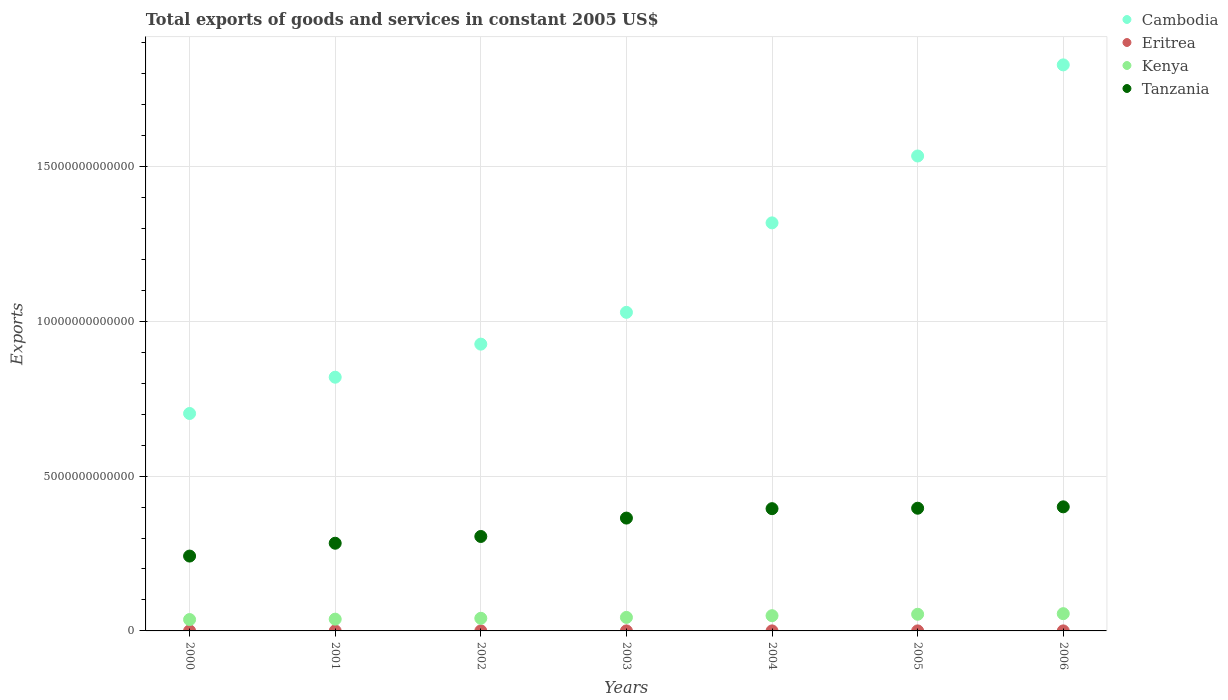Is the number of dotlines equal to the number of legend labels?
Offer a terse response. Yes. What is the total exports of goods and services in Eritrea in 2006?
Offer a terse response. 7.80e+08. Across all years, what is the maximum total exports of goods and services in Tanzania?
Make the answer very short. 4.01e+12. Across all years, what is the minimum total exports of goods and services in Tanzania?
Keep it short and to the point. 2.42e+12. What is the total total exports of goods and services in Eritrea in the graph?
Provide a short and direct response. 5.02e+09. What is the difference between the total exports of goods and services in Tanzania in 2003 and that in 2004?
Keep it short and to the point. -3.04e+11. What is the difference between the total exports of goods and services in Cambodia in 2006 and the total exports of goods and services in Kenya in 2000?
Keep it short and to the point. 1.79e+13. What is the average total exports of goods and services in Eritrea per year?
Ensure brevity in your answer.  7.17e+08. In the year 2005, what is the difference between the total exports of goods and services in Kenya and total exports of goods and services in Eritrea?
Offer a terse response. 5.37e+11. What is the ratio of the total exports of goods and services in Kenya in 2005 to that in 2006?
Your answer should be compact. 0.97. Is the difference between the total exports of goods and services in Kenya in 2000 and 2006 greater than the difference between the total exports of goods and services in Eritrea in 2000 and 2006?
Offer a terse response. No. What is the difference between the highest and the second highest total exports of goods and services in Kenya?
Give a very brief answer. 1.90e+1. What is the difference between the highest and the lowest total exports of goods and services in Cambodia?
Ensure brevity in your answer.  1.13e+13. In how many years, is the total exports of goods and services in Kenya greater than the average total exports of goods and services in Kenya taken over all years?
Make the answer very short. 3. Is the sum of the total exports of goods and services in Kenya in 2000 and 2002 greater than the maximum total exports of goods and services in Tanzania across all years?
Give a very brief answer. No. Is it the case that in every year, the sum of the total exports of goods and services in Kenya and total exports of goods and services in Cambodia  is greater than the sum of total exports of goods and services in Tanzania and total exports of goods and services in Eritrea?
Your answer should be very brief. Yes. Does the total exports of goods and services in Tanzania monotonically increase over the years?
Your answer should be very brief. Yes. Is the total exports of goods and services in Tanzania strictly greater than the total exports of goods and services in Eritrea over the years?
Offer a very short reply. Yes. How many years are there in the graph?
Your answer should be compact. 7. What is the difference between two consecutive major ticks on the Y-axis?
Your response must be concise. 5.00e+12. Are the values on the major ticks of Y-axis written in scientific E-notation?
Offer a terse response. No. Where does the legend appear in the graph?
Your answer should be compact. Top right. How are the legend labels stacked?
Your response must be concise. Vertical. What is the title of the graph?
Your answer should be compact. Total exports of goods and services in constant 2005 US$. Does "Kyrgyz Republic" appear as one of the legend labels in the graph?
Your answer should be very brief. No. What is the label or title of the X-axis?
Your answer should be very brief. Years. What is the label or title of the Y-axis?
Give a very brief answer. Exports. What is the Exports in Cambodia in 2000?
Your answer should be compact. 7.02e+12. What is the Exports in Eritrea in 2000?
Provide a short and direct response. 6.57e+08. What is the Exports of Kenya in 2000?
Your response must be concise. 3.67e+11. What is the Exports of Tanzania in 2000?
Your answer should be compact. 2.42e+12. What is the Exports in Cambodia in 2001?
Your answer should be compact. 8.19e+12. What is the Exports of Eritrea in 2001?
Offer a very short reply. 7.64e+08. What is the Exports of Kenya in 2001?
Ensure brevity in your answer.  3.80e+11. What is the Exports of Tanzania in 2001?
Offer a very short reply. 2.83e+12. What is the Exports in Cambodia in 2002?
Ensure brevity in your answer.  9.26e+12. What is the Exports of Eritrea in 2002?
Your response must be concise. 8.31e+08. What is the Exports of Kenya in 2002?
Offer a terse response. 4.07e+11. What is the Exports of Tanzania in 2002?
Your answer should be very brief. 3.05e+12. What is the Exports of Cambodia in 2003?
Your response must be concise. 1.03e+13. What is the Exports of Eritrea in 2003?
Your answer should be very brief. 6.21e+08. What is the Exports of Kenya in 2003?
Provide a short and direct response. 4.37e+11. What is the Exports in Tanzania in 2003?
Provide a short and direct response. 3.64e+12. What is the Exports in Cambodia in 2004?
Offer a terse response. 1.32e+13. What is the Exports of Eritrea in 2004?
Ensure brevity in your answer.  6.85e+08. What is the Exports in Kenya in 2004?
Offer a very short reply. 4.92e+11. What is the Exports in Tanzania in 2004?
Your answer should be very brief. 3.95e+12. What is the Exports of Cambodia in 2005?
Give a very brief answer. 1.53e+13. What is the Exports of Eritrea in 2005?
Your response must be concise. 6.78e+08. What is the Exports of Kenya in 2005?
Make the answer very short. 5.38e+11. What is the Exports of Tanzania in 2005?
Offer a terse response. 3.96e+12. What is the Exports in Cambodia in 2006?
Ensure brevity in your answer.  1.83e+13. What is the Exports in Eritrea in 2006?
Make the answer very short. 7.80e+08. What is the Exports in Kenya in 2006?
Give a very brief answer. 5.57e+11. What is the Exports of Tanzania in 2006?
Keep it short and to the point. 4.01e+12. Across all years, what is the maximum Exports of Cambodia?
Keep it short and to the point. 1.83e+13. Across all years, what is the maximum Exports in Eritrea?
Offer a very short reply. 8.31e+08. Across all years, what is the maximum Exports in Kenya?
Your answer should be very brief. 5.57e+11. Across all years, what is the maximum Exports in Tanzania?
Provide a short and direct response. 4.01e+12. Across all years, what is the minimum Exports in Cambodia?
Offer a terse response. 7.02e+12. Across all years, what is the minimum Exports in Eritrea?
Provide a short and direct response. 6.21e+08. Across all years, what is the minimum Exports in Kenya?
Offer a very short reply. 3.67e+11. Across all years, what is the minimum Exports of Tanzania?
Ensure brevity in your answer.  2.42e+12. What is the total Exports of Cambodia in the graph?
Your response must be concise. 8.15e+13. What is the total Exports of Eritrea in the graph?
Ensure brevity in your answer.  5.02e+09. What is the total Exports in Kenya in the graph?
Your response must be concise. 3.18e+12. What is the total Exports in Tanzania in the graph?
Your answer should be compact. 2.39e+13. What is the difference between the Exports of Cambodia in 2000 and that in 2001?
Provide a short and direct response. -1.17e+12. What is the difference between the Exports in Eritrea in 2000 and that in 2001?
Keep it short and to the point. -1.06e+08. What is the difference between the Exports of Kenya in 2000 and that in 2001?
Give a very brief answer. -1.32e+1. What is the difference between the Exports of Tanzania in 2000 and that in 2001?
Keep it short and to the point. -4.14e+11. What is the difference between the Exports of Cambodia in 2000 and that in 2002?
Provide a succinct answer. -2.24e+12. What is the difference between the Exports of Eritrea in 2000 and that in 2002?
Provide a short and direct response. -1.73e+08. What is the difference between the Exports in Kenya in 2000 and that in 2002?
Your response must be concise. -4.03e+1. What is the difference between the Exports of Tanzania in 2000 and that in 2002?
Offer a very short reply. -6.32e+11. What is the difference between the Exports in Cambodia in 2000 and that in 2003?
Keep it short and to the point. -3.27e+12. What is the difference between the Exports of Eritrea in 2000 and that in 2003?
Offer a terse response. 3.66e+07. What is the difference between the Exports of Kenya in 2000 and that in 2003?
Offer a very short reply. -6.97e+1. What is the difference between the Exports of Tanzania in 2000 and that in 2003?
Give a very brief answer. -1.23e+12. What is the difference between the Exports of Cambodia in 2000 and that in 2004?
Your response must be concise. -6.15e+12. What is the difference between the Exports in Eritrea in 2000 and that in 2004?
Keep it short and to the point. -2.75e+07. What is the difference between the Exports of Kenya in 2000 and that in 2004?
Offer a terse response. -1.25e+11. What is the difference between the Exports in Tanzania in 2000 and that in 2004?
Give a very brief answer. -1.53e+12. What is the difference between the Exports in Cambodia in 2000 and that in 2005?
Ensure brevity in your answer.  -8.31e+12. What is the difference between the Exports in Eritrea in 2000 and that in 2005?
Your response must be concise. -2.05e+07. What is the difference between the Exports in Kenya in 2000 and that in 2005?
Offer a very short reply. -1.71e+11. What is the difference between the Exports in Tanzania in 2000 and that in 2005?
Offer a terse response. -1.54e+12. What is the difference between the Exports of Cambodia in 2000 and that in 2006?
Offer a very short reply. -1.13e+13. What is the difference between the Exports in Eritrea in 2000 and that in 2006?
Make the answer very short. -1.23e+08. What is the difference between the Exports in Kenya in 2000 and that in 2006?
Your response must be concise. -1.90e+11. What is the difference between the Exports of Tanzania in 2000 and that in 2006?
Ensure brevity in your answer.  -1.59e+12. What is the difference between the Exports of Cambodia in 2001 and that in 2002?
Provide a succinct answer. -1.07e+12. What is the difference between the Exports in Eritrea in 2001 and that in 2002?
Give a very brief answer. -6.67e+07. What is the difference between the Exports in Kenya in 2001 and that in 2002?
Offer a terse response. -2.71e+1. What is the difference between the Exports of Tanzania in 2001 and that in 2002?
Give a very brief answer. -2.18e+11. What is the difference between the Exports in Cambodia in 2001 and that in 2003?
Your answer should be compact. -2.09e+12. What is the difference between the Exports of Eritrea in 2001 and that in 2003?
Provide a short and direct response. 1.43e+08. What is the difference between the Exports of Kenya in 2001 and that in 2003?
Offer a terse response. -5.64e+1. What is the difference between the Exports in Tanzania in 2001 and that in 2003?
Your answer should be very brief. -8.12e+11. What is the difference between the Exports in Cambodia in 2001 and that in 2004?
Offer a very short reply. -4.98e+12. What is the difference between the Exports of Eritrea in 2001 and that in 2004?
Keep it short and to the point. 7.90e+07. What is the difference between the Exports of Kenya in 2001 and that in 2004?
Ensure brevity in your answer.  -1.11e+11. What is the difference between the Exports in Tanzania in 2001 and that in 2004?
Your answer should be very brief. -1.12e+12. What is the difference between the Exports of Cambodia in 2001 and that in 2005?
Ensure brevity in your answer.  -7.14e+12. What is the difference between the Exports of Eritrea in 2001 and that in 2005?
Your response must be concise. 8.60e+07. What is the difference between the Exports of Kenya in 2001 and that in 2005?
Your answer should be compact. -1.58e+11. What is the difference between the Exports in Tanzania in 2001 and that in 2005?
Your answer should be very brief. -1.13e+12. What is the difference between the Exports in Cambodia in 2001 and that in 2006?
Give a very brief answer. -1.01e+13. What is the difference between the Exports of Eritrea in 2001 and that in 2006?
Provide a succinct answer. -1.63e+07. What is the difference between the Exports in Kenya in 2001 and that in 2006?
Provide a short and direct response. -1.77e+11. What is the difference between the Exports in Tanzania in 2001 and that in 2006?
Make the answer very short. -1.17e+12. What is the difference between the Exports of Cambodia in 2002 and that in 2003?
Your answer should be compact. -1.03e+12. What is the difference between the Exports in Eritrea in 2002 and that in 2003?
Your response must be concise. 2.10e+08. What is the difference between the Exports of Kenya in 2002 and that in 2003?
Give a very brief answer. -2.94e+1. What is the difference between the Exports of Tanzania in 2002 and that in 2003?
Your response must be concise. -5.94e+11. What is the difference between the Exports in Cambodia in 2002 and that in 2004?
Provide a short and direct response. -3.91e+12. What is the difference between the Exports of Eritrea in 2002 and that in 2004?
Give a very brief answer. 1.46e+08. What is the difference between the Exports of Kenya in 2002 and that in 2004?
Keep it short and to the point. -8.44e+1. What is the difference between the Exports of Tanzania in 2002 and that in 2004?
Keep it short and to the point. -8.98e+11. What is the difference between the Exports in Cambodia in 2002 and that in 2005?
Offer a terse response. -6.07e+12. What is the difference between the Exports of Eritrea in 2002 and that in 2005?
Provide a short and direct response. 1.53e+08. What is the difference between the Exports in Kenya in 2002 and that in 2005?
Your answer should be very brief. -1.31e+11. What is the difference between the Exports of Tanzania in 2002 and that in 2005?
Give a very brief answer. -9.12e+11. What is the difference between the Exports of Cambodia in 2002 and that in 2006?
Your answer should be very brief. -9.02e+12. What is the difference between the Exports in Eritrea in 2002 and that in 2006?
Your answer should be very brief. 5.03e+07. What is the difference between the Exports in Kenya in 2002 and that in 2006?
Provide a succinct answer. -1.50e+11. What is the difference between the Exports in Tanzania in 2002 and that in 2006?
Provide a succinct answer. -9.57e+11. What is the difference between the Exports in Cambodia in 2003 and that in 2004?
Ensure brevity in your answer.  -2.89e+12. What is the difference between the Exports in Eritrea in 2003 and that in 2004?
Offer a terse response. -6.41e+07. What is the difference between the Exports in Kenya in 2003 and that in 2004?
Provide a succinct answer. -5.50e+1. What is the difference between the Exports of Tanzania in 2003 and that in 2004?
Your answer should be very brief. -3.04e+11. What is the difference between the Exports of Cambodia in 2003 and that in 2005?
Your answer should be very brief. -5.05e+12. What is the difference between the Exports of Eritrea in 2003 and that in 2005?
Your answer should be very brief. -5.71e+07. What is the difference between the Exports of Kenya in 2003 and that in 2005?
Your answer should be compact. -1.01e+11. What is the difference between the Exports of Tanzania in 2003 and that in 2005?
Your answer should be compact. -3.18e+11. What is the difference between the Exports of Cambodia in 2003 and that in 2006?
Offer a terse response. -7.99e+12. What is the difference between the Exports in Eritrea in 2003 and that in 2006?
Your answer should be very brief. -1.59e+08. What is the difference between the Exports in Kenya in 2003 and that in 2006?
Your answer should be compact. -1.20e+11. What is the difference between the Exports of Tanzania in 2003 and that in 2006?
Give a very brief answer. -3.63e+11. What is the difference between the Exports of Cambodia in 2004 and that in 2005?
Ensure brevity in your answer.  -2.16e+12. What is the difference between the Exports in Eritrea in 2004 and that in 2005?
Your answer should be very brief. 7.06e+06. What is the difference between the Exports of Kenya in 2004 and that in 2005?
Offer a terse response. -4.61e+1. What is the difference between the Exports of Tanzania in 2004 and that in 2005?
Provide a short and direct response. -1.44e+1. What is the difference between the Exports of Cambodia in 2004 and that in 2006?
Offer a very short reply. -5.10e+12. What is the difference between the Exports of Eritrea in 2004 and that in 2006?
Make the answer very short. -9.53e+07. What is the difference between the Exports in Kenya in 2004 and that in 2006?
Offer a terse response. -6.52e+1. What is the difference between the Exports in Tanzania in 2004 and that in 2006?
Provide a succinct answer. -5.89e+1. What is the difference between the Exports in Cambodia in 2005 and that in 2006?
Your response must be concise. -2.94e+12. What is the difference between the Exports in Eritrea in 2005 and that in 2006?
Make the answer very short. -1.02e+08. What is the difference between the Exports in Kenya in 2005 and that in 2006?
Keep it short and to the point. -1.90e+1. What is the difference between the Exports in Tanzania in 2005 and that in 2006?
Make the answer very short. -4.45e+1. What is the difference between the Exports of Cambodia in 2000 and the Exports of Eritrea in 2001?
Make the answer very short. 7.02e+12. What is the difference between the Exports in Cambodia in 2000 and the Exports in Kenya in 2001?
Offer a terse response. 6.64e+12. What is the difference between the Exports in Cambodia in 2000 and the Exports in Tanzania in 2001?
Give a very brief answer. 4.19e+12. What is the difference between the Exports in Eritrea in 2000 and the Exports in Kenya in 2001?
Keep it short and to the point. -3.80e+11. What is the difference between the Exports in Eritrea in 2000 and the Exports in Tanzania in 2001?
Make the answer very short. -2.83e+12. What is the difference between the Exports of Kenya in 2000 and the Exports of Tanzania in 2001?
Keep it short and to the point. -2.46e+12. What is the difference between the Exports of Cambodia in 2000 and the Exports of Eritrea in 2002?
Ensure brevity in your answer.  7.02e+12. What is the difference between the Exports in Cambodia in 2000 and the Exports in Kenya in 2002?
Your response must be concise. 6.61e+12. What is the difference between the Exports of Cambodia in 2000 and the Exports of Tanzania in 2002?
Your response must be concise. 3.97e+12. What is the difference between the Exports in Eritrea in 2000 and the Exports in Kenya in 2002?
Your answer should be compact. -4.07e+11. What is the difference between the Exports of Eritrea in 2000 and the Exports of Tanzania in 2002?
Give a very brief answer. -3.05e+12. What is the difference between the Exports in Kenya in 2000 and the Exports in Tanzania in 2002?
Provide a succinct answer. -2.68e+12. What is the difference between the Exports in Cambodia in 2000 and the Exports in Eritrea in 2003?
Offer a very short reply. 7.02e+12. What is the difference between the Exports in Cambodia in 2000 and the Exports in Kenya in 2003?
Offer a terse response. 6.58e+12. What is the difference between the Exports in Cambodia in 2000 and the Exports in Tanzania in 2003?
Offer a terse response. 3.38e+12. What is the difference between the Exports in Eritrea in 2000 and the Exports in Kenya in 2003?
Offer a terse response. -4.36e+11. What is the difference between the Exports in Eritrea in 2000 and the Exports in Tanzania in 2003?
Keep it short and to the point. -3.64e+12. What is the difference between the Exports in Kenya in 2000 and the Exports in Tanzania in 2003?
Offer a very short reply. -3.28e+12. What is the difference between the Exports in Cambodia in 2000 and the Exports in Eritrea in 2004?
Ensure brevity in your answer.  7.02e+12. What is the difference between the Exports in Cambodia in 2000 and the Exports in Kenya in 2004?
Your answer should be compact. 6.53e+12. What is the difference between the Exports in Cambodia in 2000 and the Exports in Tanzania in 2004?
Give a very brief answer. 3.07e+12. What is the difference between the Exports of Eritrea in 2000 and the Exports of Kenya in 2004?
Your answer should be compact. -4.91e+11. What is the difference between the Exports in Eritrea in 2000 and the Exports in Tanzania in 2004?
Your answer should be compact. -3.95e+12. What is the difference between the Exports in Kenya in 2000 and the Exports in Tanzania in 2004?
Make the answer very short. -3.58e+12. What is the difference between the Exports of Cambodia in 2000 and the Exports of Eritrea in 2005?
Your response must be concise. 7.02e+12. What is the difference between the Exports in Cambodia in 2000 and the Exports in Kenya in 2005?
Provide a short and direct response. 6.48e+12. What is the difference between the Exports of Cambodia in 2000 and the Exports of Tanzania in 2005?
Ensure brevity in your answer.  3.06e+12. What is the difference between the Exports of Eritrea in 2000 and the Exports of Kenya in 2005?
Provide a short and direct response. -5.37e+11. What is the difference between the Exports in Eritrea in 2000 and the Exports in Tanzania in 2005?
Your answer should be compact. -3.96e+12. What is the difference between the Exports in Kenya in 2000 and the Exports in Tanzania in 2005?
Keep it short and to the point. -3.59e+12. What is the difference between the Exports in Cambodia in 2000 and the Exports in Eritrea in 2006?
Your answer should be very brief. 7.02e+12. What is the difference between the Exports of Cambodia in 2000 and the Exports of Kenya in 2006?
Your answer should be very brief. 6.46e+12. What is the difference between the Exports of Cambodia in 2000 and the Exports of Tanzania in 2006?
Provide a succinct answer. 3.01e+12. What is the difference between the Exports in Eritrea in 2000 and the Exports in Kenya in 2006?
Your answer should be compact. -5.56e+11. What is the difference between the Exports of Eritrea in 2000 and the Exports of Tanzania in 2006?
Give a very brief answer. -4.01e+12. What is the difference between the Exports of Kenya in 2000 and the Exports of Tanzania in 2006?
Provide a short and direct response. -3.64e+12. What is the difference between the Exports in Cambodia in 2001 and the Exports in Eritrea in 2002?
Your answer should be very brief. 8.19e+12. What is the difference between the Exports of Cambodia in 2001 and the Exports of Kenya in 2002?
Provide a short and direct response. 7.78e+12. What is the difference between the Exports of Cambodia in 2001 and the Exports of Tanzania in 2002?
Provide a short and direct response. 5.14e+12. What is the difference between the Exports in Eritrea in 2001 and the Exports in Kenya in 2002?
Offer a very short reply. -4.07e+11. What is the difference between the Exports of Eritrea in 2001 and the Exports of Tanzania in 2002?
Your answer should be very brief. -3.05e+12. What is the difference between the Exports in Kenya in 2001 and the Exports in Tanzania in 2002?
Offer a very short reply. -2.67e+12. What is the difference between the Exports of Cambodia in 2001 and the Exports of Eritrea in 2003?
Ensure brevity in your answer.  8.19e+12. What is the difference between the Exports of Cambodia in 2001 and the Exports of Kenya in 2003?
Your answer should be compact. 7.75e+12. What is the difference between the Exports of Cambodia in 2001 and the Exports of Tanzania in 2003?
Keep it short and to the point. 4.55e+12. What is the difference between the Exports in Eritrea in 2001 and the Exports in Kenya in 2003?
Your answer should be compact. -4.36e+11. What is the difference between the Exports in Eritrea in 2001 and the Exports in Tanzania in 2003?
Offer a very short reply. -3.64e+12. What is the difference between the Exports of Kenya in 2001 and the Exports of Tanzania in 2003?
Your response must be concise. -3.26e+12. What is the difference between the Exports of Cambodia in 2001 and the Exports of Eritrea in 2004?
Provide a succinct answer. 8.19e+12. What is the difference between the Exports in Cambodia in 2001 and the Exports in Kenya in 2004?
Ensure brevity in your answer.  7.70e+12. What is the difference between the Exports of Cambodia in 2001 and the Exports of Tanzania in 2004?
Offer a terse response. 4.24e+12. What is the difference between the Exports in Eritrea in 2001 and the Exports in Kenya in 2004?
Ensure brevity in your answer.  -4.91e+11. What is the difference between the Exports of Eritrea in 2001 and the Exports of Tanzania in 2004?
Offer a very short reply. -3.95e+12. What is the difference between the Exports of Kenya in 2001 and the Exports of Tanzania in 2004?
Offer a terse response. -3.57e+12. What is the difference between the Exports of Cambodia in 2001 and the Exports of Eritrea in 2005?
Give a very brief answer. 8.19e+12. What is the difference between the Exports of Cambodia in 2001 and the Exports of Kenya in 2005?
Your answer should be very brief. 7.65e+12. What is the difference between the Exports of Cambodia in 2001 and the Exports of Tanzania in 2005?
Offer a very short reply. 4.23e+12. What is the difference between the Exports of Eritrea in 2001 and the Exports of Kenya in 2005?
Make the answer very short. -5.37e+11. What is the difference between the Exports in Eritrea in 2001 and the Exports in Tanzania in 2005?
Your answer should be very brief. -3.96e+12. What is the difference between the Exports of Kenya in 2001 and the Exports of Tanzania in 2005?
Make the answer very short. -3.58e+12. What is the difference between the Exports in Cambodia in 2001 and the Exports in Eritrea in 2006?
Your response must be concise. 8.19e+12. What is the difference between the Exports of Cambodia in 2001 and the Exports of Kenya in 2006?
Keep it short and to the point. 7.63e+12. What is the difference between the Exports in Cambodia in 2001 and the Exports in Tanzania in 2006?
Your response must be concise. 4.19e+12. What is the difference between the Exports of Eritrea in 2001 and the Exports of Kenya in 2006?
Offer a very short reply. -5.56e+11. What is the difference between the Exports in Eritrea in 2001 and the Exports in Tanzania in 2006?
Your answer should be very brief. -4.01e+12. What is the difference between the Exports of Kenya in 2001 and the Exports of Tanzania in 2006?
Your answer should be compact. -3.63e+12. What is the difference between the Exports of Cambodia in 2002 and the Exports of Eritrea in 2003?
Offer a terse response. 9.26e+12. What is the difference between the Exports in Cambodia in 2002 and the Exports in Kenya in 2003?
Make the answer very short. 8.82e+12. What is the difference between the Exports of Cambodia in 2002 and the Exports of Tanzania in 2003?
Provide a short and direct response. 5.62e+12. What is the difference between the Exports of Eritrea in 2002 and the Exports of Kenya in 2003?
Offer a very short reply. -4.36e+11. What is the difference between the Exports in Eritrea in 2002 and the Exports in Tanzania in 2003?
Ensure brevity in your answer.  -3.64e+12. What is the difference between the Exports of Kenya in 2002 and the Exports of Tanzania in 2003?
Your answer should be very brief. -3.24e+12. What is the difference between the Exports of Cambodia in 2002 and the Exports of Eritrea in 2004?
Your response must be concise. 9.26e+12. What is the difference between the Exports in Cambodia in 2002 and the Exports in Kenya in 2004?
Give a very brief answer. 8.77e+12. What is the difference between the Exports of Cambodia in 2002 and the Exports of Tanzania in 2004?
Ensure brevity in your answer.  5.31e+12. What is the difference between the Exports in Eritrea in 2002 and the Exports in Kenya in 2004?
Ensure brevity in your answer.  -4.91e+11. What is the difference between the Exports in Eritrea in 2002 and the Exports in Tanzania in 2004?
Give a very brief answer. -3.95e+12. What is the difference between the Exports in Kenya in 2002 and the Exports in Tanzania in 2004?
Keep it short and to the point. -3.54e+12. What is the difference between the Exports in Cambodia in 2002 and the Exports in Eritrea in 2005?
Your response must be concise. 9.26e+12. What is the difference between the Exports in Cambodia in 2002 and the Exports in Kenya in 2005?
Ensure brevity in your answer.  8.72e+12. What is the difference between the Exports of Cambodia in 2002 and the Exports of Tanzania in 2005?
Offer a very short reply. 5.30e+12. What is the difference between the Exports in Eritrea in 2002 and the Exports in Kenya in 2005?
Offer a very short reply. -5.37e+11. What is the difference between the Exports in Eritrea in 2002 and the Exports in Tanzania in 2005?
Give a very brief answer. -3.96e+12. What is the difference between the Exports in Kenya in 2002 and the Exports in Tanzania in 2005?
Your response must be concise. -3.55e+12. What is the difference between the Exports of Cambodia in 2002 and the Exports of Eritrea in 2006?
Give a very brief answer. 9.26e+12. What is the difference between the Exports of Cambodia in 2002 and the Exports of Kenya in 2006?
Your answer should be compact. 8.70e+12. What is the difference between the Exports of Cambodia in 2002 and the Exports of Tanzania in 2006?
Your answer should be very brief. 5.25e+12. What is the difference between the Exports in Eritrea in 2002 and the Exports in Kenya in 2006?
Provide a succinct answer. -5.56e+11. What is the difference between the Exports in Eritrea in 2002 and the Exports in Tanzania in 2006?
Offer a terse response. -4.01e+12. What is the difference between the Exports in Kenya in 2002 and the Exports in Tanzania in 2006?
Provide a succinct answer. -3.60e+12. What is the difference between the Exports of Cambodia in 2003 and the Exports of Eritrea in 2004?
Ensure brevity in your answer.  1.03e+13. What is the difference between the Exports in Cambodia in 2003 and the Exports in Kenya in 2004?
Provide a short and direct response. 9.79e+12. What is the difference between the Exports in Cambodia in 2003 and the Exports in Tanzania in 2004?
Ensure brevity in your answer.  6.34e+12. What is the difference between the Exports of Eritrea in 2003 and the Exports of Kenya in 2004?
Offer a very short reply. -4.91e+11. What is the difference between the Exports of Eritrea in 2003 and the Exports of Tanzania in 2004?
Your answer should be compact. -3.95e+12. What is the difference between the Exports in Kenya in 2003 and the Exports in Tanzania in 2004?
Ensure brevity in your answer.  -3.51e+12. What is the difference between the Exports of Cambodia in 2003 and the Exports of Eritrea in 2005?
Offer a very short reply. 1.03e+13. What is the difference between the Exports in Cambodia in 2003 and the Exports in Kenya in 2005?
Ensure brevity in your answer.  9.75e+12. What is the difference between the Exports of Cambodia in 2003 and the Exports of Tanzania in 2005?
Make the answer very short. 6.32e+12. What is the difference between the Exports of Eritrea in 2003 and the Exports of Kenya in 2005?
Your answer should be compact. -5.37e+11. What is the difference between the Exports in Eritrea in 2003 and the Exports in Tanzania in 2005?
Give a very brief answer. -3.96e+12. What is the difference between the Exports of Kenya in 2003 and the Exports of Tanzania in 2005?
Offer a very short reply. -3.52e+12. What is the difference between the Exports of Cambodia in 2003 and the Exports of Eritrea in 2006?
Make the answer very short. 1.03e+13. What is the difference between the Exports of Cambodia in 2003 and the Exports of Kenya in 2006?
Give a very brief answer. 9.73e+12. What is the difference between the Exports in Cambodia in 2003 and the Exports in Tanzania in 2006?
Provide a succinct answer. 6.28e+12. What is the difference between the Exports in Eritrea in 2003 and the Exports in Kenya in 2006?
Keep it short and to the point. -5.56e+11. What is the difference between the Exports of Eritrea in 2003 and the Exports of Tanzania in 2006?
Keep it short and to the point. -4.01e+12. What is the difference between the Exports of Kenya in 2003 and the Exports of Tanzania in 2006?
Give a very brief answer. -3.57e+12. What is the difference between the Exports in Cambodia in 2004 and the Exports in Eritrea in 2005?
Your answer should be very brief. 1.32e+13. What is the difference between the Exports in Cambodia in 2004 and the Exports in Kenya in 2005?
Your answer should be very brief. 1.26e+13. What is the difference between the Exports of Cambodia in 2004 and the Exports of Tanzania in 2005?
Offer a terse response. 9.21e+12. What is the difference between the Exports in Eritrea in 2004 and the Exports in Kenya in 2005?
Your answer should be very brief. -5.37e+11. What is the difference between the Exports of Eritrea in 2004 and the Exports of Tanzania in 2005?
Your answer should be compact. -3.96e+12. What is the difference between the Exports in Kenya in 2004 and the Exports in Tanzania in 2005?
Provide a succinct answer. -3.47e+12. What is the difference between the Exports of Cambodia in 2004 and the Exports of Eritrea in 2006?
Give a very brief answer. 1.32e+13. What is the difference between the Exports in Cambodia in 2004 and the Exports in Kenya in 2006?
Ensure brevity in your answer.  1.26e+13. What is the difference between the Exports in Cambodia in 2004 and the Exports in Tanzania in 2006?
Your answer should be very brief. 9.17e+12. What is the difference between the Exports of Eritrea in 2004 and the Exports of Kenya in 2006?
Your answer should be very brief. -5.56e+11. What is the difference between the Exports in Eritrea in 2004 and the Exports in Tanzania in 2006?
Ensure brevity in your answer.  -4.01e+12. What is the difference between the Exports of Kenya in 2004 and the Exports of Tanzania in 2006?
Keep it short and to the point. -3.51e+12. What is the difference between the Exports in Cambodia in 2005 and the Exports in Eritrea in 2006?
Offer a terse response. 1.53e+13. What is the difference between the Exports of Cambodia in 2005 and the Exports of Kenya in 2006?
Keep it short and to the point. 1.48e+13. What is the difference between the Exports of Cambodia in 2005 and the Exports of Tanzania in 2006?
Your answer should be very brief. 1.13e+13. What is the difference between the Exports in Eritrea in 2005 and the Exports in Kenya in 2006?
Offer a terse response. -5.56e+11. What is the difference between the Exports of Eritrea in 2005 and the Exports of Tanzania in 2006?
Offer a terse response. -4.01e+12. What is the difference between the Exports of Kenya in 2005 and the Exports of Tanzania in 2006?
Offer a terse response. -3.47e+12. What is the average Exports of Cambodia per year?
Your response must be concise. 1.16e+13. What is the average Exports of Eritrea per year?
Your response must be concise. 7.17e+08. What is the average Exports of Kenya per year?
Make the answer very short. 4.54e+11. What is the average Exports in Tanzania per year?
Your response must be concise. 3.41e+12. In the year 2000, what is the difference between the Exports in Cambodia and Exports in Eritrea?
Your answer should be very brief. 7.02e+12. In the year 2000, what is the difference between the Exports of Cambodia and Exports of Kenya?
Your response must be concise. 6.65e+12. In the year 2000, what is the difference between the Exports of Cambodia and Exports of Tanzania?
Keep it short and to the point. 4.60e+12. In the year 2000, what is the difference between the Exports of Eritrea and Exports of Kenya?
Make the answer very short. -3.66e+11. In the year 2000, what is the difference between the Exports of Eritrea and Exports of Tanzania?
Ensure brevity in your answer.  -2.42e+12. In the year 2000, what is the difference between the Exports in Kenya and Exports in Tanzania?
Make the answer very short. -2.05e+12. In the year 2001, what is the difference between the Exports in Cambodia and Exports in Eritrea?
Provide a succinct answer. 8.19e+12. In the year 2001, what is the difference between the Exports in Cambodia and Exports in Kenya?
Provide a short and direct response. 7.81e+12. In the year 2001, what is the difference between the Exports in Cambodia and Exports in Tanzania?
Offer a very short reply. 5.36e+12. In the year 2001, what is the difference between the Exports of Eritrea and Exports of Kenya?
Your answer should be compact. -3.80e+11. In the year 2001, what is the difference between the Exports in Eritrea and Exports in Tanzania?
Ensure brevity in your answer.  -2.83e+12. In the year 2001, what is the difference between the Exports in Kenya and Exports in Tanzania?
Ensure brevity in your answer.  -2.45e+12. In the year 2002, what is the difference between the Exports in Cambodia and Exports in Eritrea?
Offer a very short reply. 9.26e+12. In the year 2002, what is the difference between the Exports in Cambodia and Exports in Kenya?
Make the answer very short. 8.85e+12. In the year 2002, what is the difference between the Exports of Cambodia and Exports of Tanzania?
Provide a succinct answer. 6.21e+12. In the year 2002, what is the difference between the Exports of Eritrea and Exports of Kenya?
Keep it short and to the point. -4.07e+11. In the year 2002, what is the difference between the Exports of Eritrea and Exports of Tanzania?
Provide a succinct answer. -3.05e+12. In the year 2002, what is the difference between the Exports of Kenya and Exports of Tanzania?
Your answer should be compact. -2.64e+12. In the year 2003, what is the difference between the Exports in Cambodia and Exports in Eritrea?
Make the answer very short. 1.03e+13. In the year 2003, what is the difference between the Exports of Cambodia and Exports of Kenya?
Provide a succinct answer. 9.85e+12. In the year 2003, what is the difference between the Exports of Cambodia and Exports of Tanzania?
Offer a terse response. 6.64e+12. In the year 2003, what is the difference between the Exports in Eritrea and Exports in Kenya?
Provide a short and direct response. -4.36e+11. In the year 2003, what is the difference between the Exports of Eritrea and Exports of Tanzania?
Ensure brevity in your answer.  -3.64e+12. In the year 2003, what is the difference between the Exports of Kenya and Exports of Tanzania?
Offer a very short reply. -3.21e+12. In the year 2004, what is the difference between the Exports of Cambodia and Exports of Eritrea?
Ensure brevity in your answer.  1.32e+13. In the year 2004, what is the difference between the Exports of Cambodia and Exports of Kenya?
Your answer should be very brief. 1.27e+13. In the year 2004, what is the difference between the Exports of Cambodia and Exports of Tanzania?
Keep it short and to the point. 9.23e+12. In the year 2004, what is the difference between the Exports in Eritrea and Exports in Kenya?
Offer a terse response. -4.91e+11. In the year 2004, what is the difference between the Exports in Eritrea and Exports in Tanzania?
Provide a succinct answer. -3.95e+12. In the year 2004, what is the difference between the Exports of Kenya and Exports of Tanzania?
Provide a short and direct response. -3.46e+12. In the year 2005, what is the difference between the Exports in Cambodia and Exports in Eritrea?
Provide a short and direct response. 1.53e+13. In the year 2005, what is the difference between the Exports in Cambodia and Exports in Kenya?
Your answer should be very brief. 1.48e+13. In the year 2005, what is the difference between the Exports of Cambodia and Exports of Tanzania?
Your response must be concise. 1.14e+13. In the year 2005, what is the difference between the Exports in Eritrea and Exports in Kenya?
Keep it short and to the point. -5.37e+11. In the year 2005, what is the difference between the Exports of Eritrea and Exports of Tanzania?
Your answer should be very brief. -3.96e+12. In the year 2005, what is the difference between the Exports of Kenya and Exports of Tanzania?
Give a very brief answer. -3.42e+12. In the year 2006, what is the difference between the Exports in Cambodia and Exports in Eritrea?
Ensure brevity in your answer.  1.83e+13. In the year 2006, what is the difference between the Exports of Cambodia and Exports of Kenya?
Your answer should be compact. 1.77e+13. In the year 2006, what is the difference between the Exports of Cambodia and Exports of Tanzania?
Offer a very short reply. 1.43e+13. In the year 2006, what is the difference between the Exports in Eritrea and Exports in Kenya?
Your answer should be compact. -5.56e+11. In the year 2006, what is the difference between the Exports in Eritrea and Exports in Tanzania?
Your answer should be compact. -4.01e+12. In the year 2006, what is the difference between the Exports in Kenya and Exports in Tanzania?
Your answer should be very brief. -3.45e+12. What is the ratio of the Exports in Cambodia in 2000 to that in 2001?
Your answer should be very brief. 0.86. What is the ratio of the Exports in Eritrea in 2000 to that in 2001?
Keep it short and to the point. 0.86. What is the ratio of the Exports in Kenya in 2000 to that in 2001?
Keep it short and to the point. 0.97. What is the ratio of the Exports of Tanzania in 2000 to that in 2001?
Offer a terse response. 0.85. What is the ratio of the Exports in Cambodia in 2000 to that in 2002?
Offer a terse response. 0.76. What is the ratio of the Exports in Eritrea in 2000 to that in 2002?
Offer a terse response. 0.79. What is the ratio of the Exports of Kenya in 2000 to that in 2002?
Your answer should be very brief. 0.9. What is the ratio of the Exports of Tanzania in 2000 to that in 2002?
Your answer should be compact. 0.79. What is the ratio of the Exports in Cambodia in 2000 to that in 2003?
Offer a very short reply. 0.68. What is the ratio of the Exports of Eritrea in 2000 to that in 2003?
Provide a succinct answer. 1.06. What is the ratio of the Exports of Kenya in 2000 to that in 2003?
Provide a short and direct response. 0.84. What is the ratio of the Exports in Tanzania in 2000 to that in 2003?
Keep it short and to the point. 0.66. What is the ratio of the Exports of Cambodia in 2000 to that in 2004?
Offer a terse response. 0.53. What is the ratio of the Exports in Eritrea in 2000 to that in 2004?
Ensure brevity in your answer.  0.96. What is the ratio of the Exports of Kenya in 2000 to that in 2004?
Give a very brief answer. 0.75. What is the ratio of the Exports in Tanzania in 2000 to that in 2004?
Give a very brief answer. 0.61. What is the ratio of the Exports of Cambodia in 2000 to that in 2005?
Keep it short and to the point. 0.46. What is the ratio of the Exports of Eritrea in 2000 to that in 2005?
Provide a short and direct response. 0.97. What is the ratio of the Exports in Kenya in 2000 to that in 2005?
Offer a terse response. 0.68. What is the ratio of the Exports in Tanzania in 2000 to that in 2005?
Your answer should be very brief. 0.61. What is the ratio of the Exports in Cambodia in 2000 to that in 2006?
Provide a short and direct response. 0.38. What is the ratio of the Exports in Eritrea in 2000 to that in 2006?
Your answer should be compact. 0.84. What is the ratio of the Exports of Kenya in 2000 to that in 2006?
Your response must be concise. 0.66. What is the ratio of the Exports in Tanzania in 2000 to that in 2006?
Your answer should be very brief. 0.6. What is the ratio of the Exports of Cambodia in 2001 to that in 2002?
Provide a succinct answer. 0.88. What is the ratio of the Exports in Eritrea in 2001 to that in 2002?
Your response must be concise. 0.92. What is the ratio of the Exports in Kenya in 2001 to that in 2002?
Your response must be concise. 0.93. What is the ratio of the Exports of Tanzania in 2001 to that in 2002?
Your answer should be very brief. 0.93. What is the ratio of the Exports in Cambodia in 2001 to that in 2003?
Keep it short and to the point. 0.8. What is the ratio of the Exports in Eritrea in 2001 to that in 2003?
Give a very brief answer. 1.23. What is the ratio of the Exports in Kenya in 2001 to that in 2003?
Provide a succinct answer. 0.87. What is the ratio of the Exports of Tanzania in 2001 to that in 2003?
Your answer should be compact. 0.78. What is the ratio of the Exports in Cambodia in 2001 to that in 2004?
Keep it short and to the point. 0.62. What is the ratio of the Exports of Eritrea in 2001 to that in 2004?
Ensure brevity in your answer.  1.12. What is the ratio of the Exports in Kenya in 2001 to that in 2004?
Offer a very short reply. 0.77. What is the ratio of the Exports in Tanzania in 2001 to that in 2004?
Give a very brief answer. 0.72. What is the ratio of the Exports in Cambodia in 2001 to that in 2005?
Ensure brevity in your answer.  0.53. What is the ratio of the Exports of Eritrea in 2001 to that in 2005?
Your answer should be compact. 1.13. What is the ratio of the Exports of Kenya in 2001 to that in 2005?
Your answer should be very brief. 0.71. What is the ratio of the Exports in Tanzania in 2001 to that in 2005?
Your answer should be very brief. 0.71. What is the ratio of the Exports of Cambodia in 2001 to that in 2006?
Your answer should be very brief. 0.45. What is the ratio of the Exports of Eritrea in 2001 to that in 2006?
Give a very brief answer. 0.98. What is the ratio of the Exports of Kenya in 2001 to that in 2006?
Offer a very short reply. 0.68. What is the ratio of the Exports of Tanzania in 2001 to that in 2006?
Offer a very short reply. 0.71. What is the ratio of the Exports of Cambodia in 2002 to that in 2003?
Your answer should be very brief. 0.9. What is the ratio of the Exports of Eritrea in 2002 to that in 2003?
Provide a succinct answer. 1.34. What is the ratio of the Exports of Kenya in 2002 to that in 2003?
Your answer should be compact. 0.93. What is the ratio of the Exports in Tanzania in 2002 to that in 2003?
Your answer should be compact. 0.84. What is the ratio of the Exports of Cambodia in 2002 to that in 2004?
Offer a very short reply. 0.7. What is the ratio of the Exports in Eritrea in 2002 to that in 2004?
Offer a very short reply. 1.21. What is the ratio of the Exports in Kenya in 2002 to that in 2004?
Ensure brevity in your answer.  0.83. What is the ratio of the Exports in Tanzania in 2002 to that in 2004?
Offer a terse response. 0.77. What is the ratio of the Exports of Cambodia in 2002 to that in 2005?
Your answer should be very brief. 0.6. What is the ratio of the Exports in Eritrea in 2002 to that in 2005?
Your answer should be very brief. 1.23. What is the ratio of the Exports in Kenya in 2002 to that in 2005?
Give a very brief answer. 0.76. What is the ratio of the Exports in Tanzania in 2002 to that in 2005?
Offer a terse response. 0.77. What is the ratio of the Exports of Cambodia in 2002 to that in 2006?
Ensure brevity in your answer.  0.51. What is the ratio of the Exports in Eritrea in 2002 to that in 2006?
Your response must be concise. 1.06. What is the ratio of the Exports of Kenya in 2002 to that in 2006?
Keep it short and to the point. 0.73. What is the ratio of the Exports of Tanzania in 2002 to that in 2006?
Your answer should be compact. 0.76. What is the ratio of the Exports of Cambodia in 2003 to that in 2004?
Ensure brevity in your answer.  0.78. What is the ratio of the Exports in Eritrea in 2003 to that in 2004?
Offer a terse response. 0.91. What is the ratio of the Exports of Kenya in 2003 to that in 2004?
Make the answer very short. 0.89. What is the ratio of the Exports of Tanzania in 2003 to that in 2004?
Offer a very short reply. 0.92. What is the ratio of the Exports of Cambodia in 2003 to that in 2005?
Your answer should be compact. 0.67. What is the ratio of the Exports of Eritrea in 2003 to that in 2005?
Provide a short and direct response. 0.92. What is the ratio of the Exports of Kenya in 2003 to that in 2005?
Your answer should be compact. 0.81. What is the ratio of the Exports in Tanzania in 2003 to that in 2005?
Provide a short and direct response. 0.92. What is the ratio of the Exports in Cambodia in 2003 to that in 2006?
Make the answer very short. 0.56. What is the ratio of the Exports of Eritrea in 2003 to that in 2006?
Your answer should be compact. 0.8. What is the ratio of the Exports in Kenya in 2003 to that in 2006?
Offer a terse response. 0.78. What is the ratio of the Exports of Tanzania in 2003 to that in 2006?
Your response must be concise. 0.91. What is the ratio of the Exports of Cambodia in 2004 to that in 2005?
Keep it short and to the point. 0.86. What is the ratio of the Exports of Eritrea in 2004 to that in 2005?
Keep it short and to the point. 1.01. What is the ratio of the Exports of Kenya in 2004 to that in 2005?
Make the answer very short. 0.91. What is the ratio of the Exports of Cambodia in 2004 to that in 2006?
Offer a very short reply. 0.72. What is the ratio of the Exports in Eritrea in 2004 to that in 2006?
Keep it short and to the point. 0.88. What is the ratio of the Exports in Kenya in 2004 to that in 2006?
Provide a succinct answer. 0.88. What is the ratio of the Exports of Tanzania in 2004 to that in 2006?
Your answer should be compact. 0.99. What is the ratio of the Exports of Cambodia in 2005 to that in 2006?
Ensure brevity in your answer.  0.84. What is the ratio of the Exports of Eritrea in 2005 to that in 2006?
Offer a terse response. 0.87. What is the ratio of the Exports of Kenya in 2005 to that in 2006?
Your answer should be very brief. 0.97. What is the ratio of the Exports in Tanzania in 2005 to that in 2006?
Make the answer very short. 0.99. What is the difference between the highest and the second highest Exports of Cambodia?
Provide a short and direct response. 2.94e+12. What is the difference between the highest and the second highest Exports of Eritrea?
Provide a short and direct response. 5.03e+07. What is the difference between the highest and the second highest Exports of Kenya?
Offer a very short reply. 1.90e+1. What is the difference between the highest and the second highest Exports in Tanzania?
Your answer should be compact. 4.45e+1. What is the difference between the highest and the lowest Exports in Cambodia?
Offer a terse response. 1.13e+13. What is the difference between the highest and the lowest Exports of Eritrea?
Offer a very short reply. 2.10e+08. What is the difference between the highest and the lowest Exports of Kenya?
Provide a short and direct response. 1.90e+11. What is the difference between the highest and the lowest Exports in Tanzania?
Your response must be concise. 1.59e+12. 